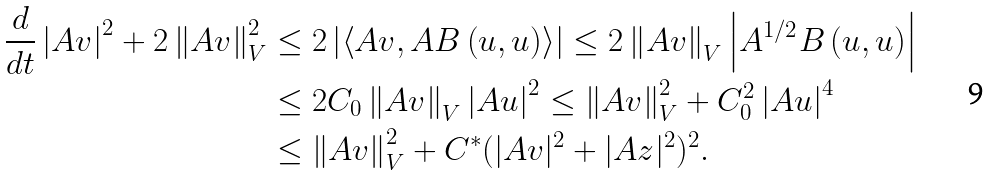Convert formula to latex. <formula><loc_0><loc_0><loc_500><loc_500>\frac { d } { d t } \left | A v \right | ^ { 2 } + 2 \left \| A v \right \| _ { V } ^ { 2 } & \leq 2 \left | \left \langle A v , A B \left ( u , u \right ) \right \rangle \right | \leq 2 \left \| A v \right \| _ { V } \left | A ^ { 1 / 2 } B \left ( u , u \right ) \right | \\ & \leq 2 C _ { 0 } \left \| A v \right \| _ { V } \left | A u \right | ^ { 2 } \leq \left \| A v \right \| _ { V } ^ { 2 } + C _ { 0 } ^ { 2 } \left | A u \right | ^ { 4 } \\ & \leq \left \| A v \right \| _ { V } ^ { 2 } + C ^ { \ast } ( | A v | ^ { 2 } + | A z | ^ { 2 } ) ^ { 2 } .</formula> 